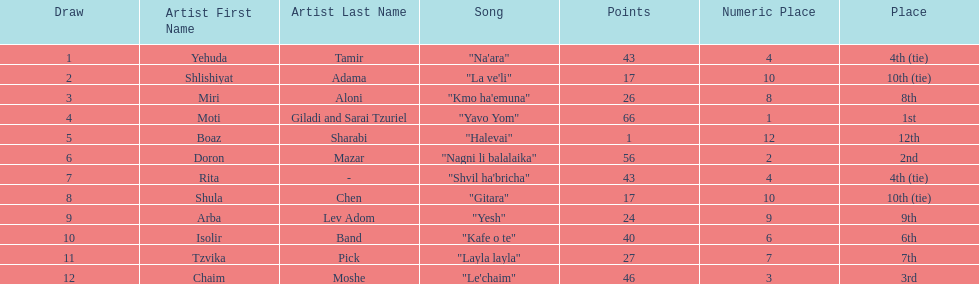What artist received the least amount of points in the competition? Boaz Sharabi. 